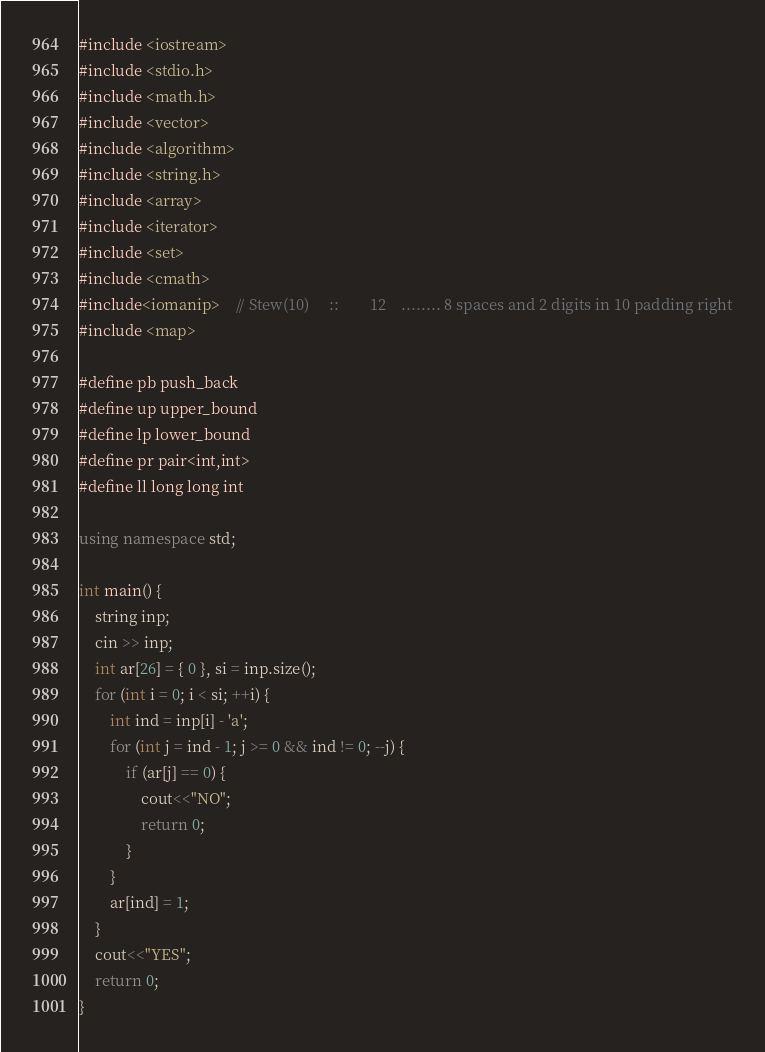Convert code to text. <code><loc_0><loc_0><loc_500><loc_500><_C++_>#include <iostream>
#include <stdio.h>
#include <math.h>
#include <vector>
#include <algorithm>
#include <string.h>
#include <array>
#include <iterator>
#include <set>
#include <cmath>
#include<iomanip>	// Stew(10)		::        12	........ 8 spaces and 2 digits in 10 padding right
#include <map>

#define pb push_back
#define up upper_bound
#define lp lower_bound
#define pr pair<int,int>
#define ll long long int

using namespace std;

int main() {
	string inp;
	cin >> inp;
	int ar[26] = { 0 }, si = inp.size();
	for (int i = 0; i < si; ++i) {
		int ind = inp[i] - 'a';
		for (int j = ind - 1; j >= 0 && ind != 0; --j) {
			if (ar[j] == 0) {
				cout<<"NO";
				return 0;
			}
		}
		ar[ind] = 1;
	}
	cout<<"YES";
	return 0;
}
</code> 